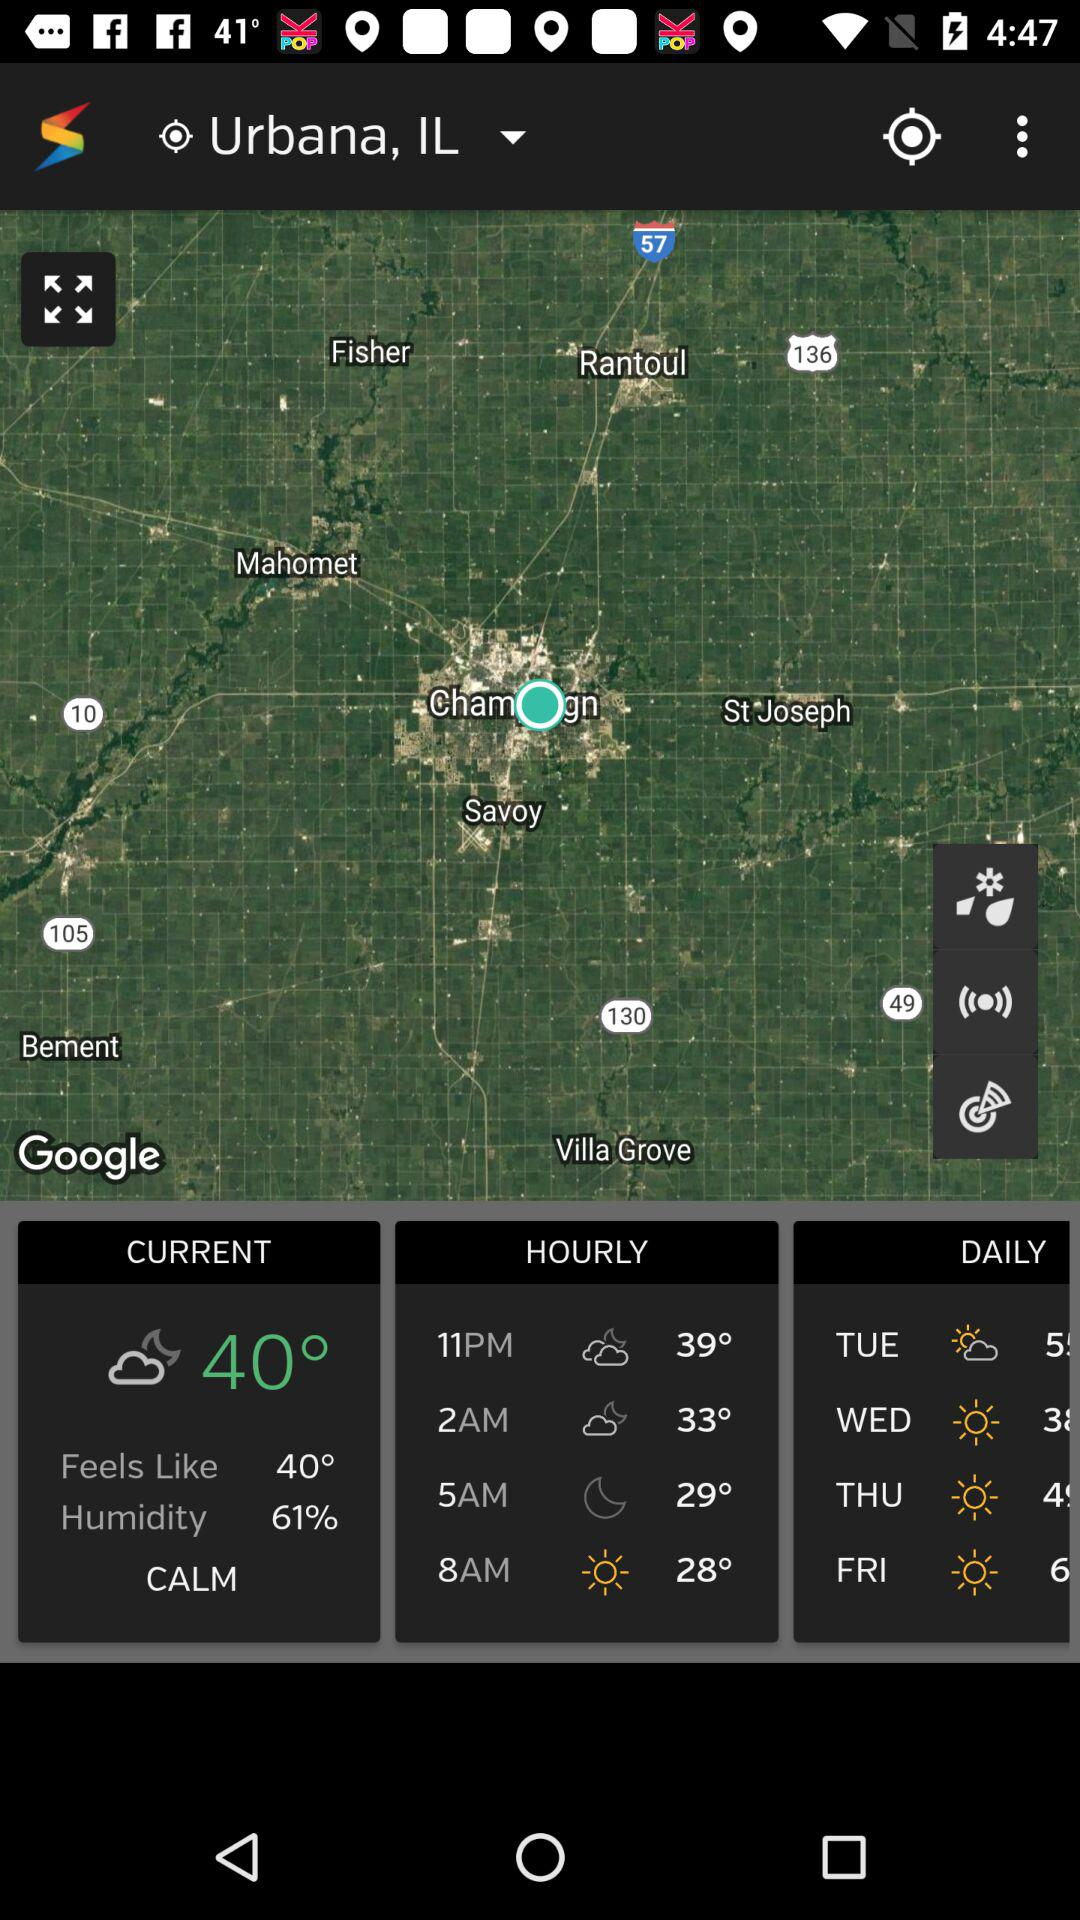How does the weather feel like? The weather feels like 40°. 